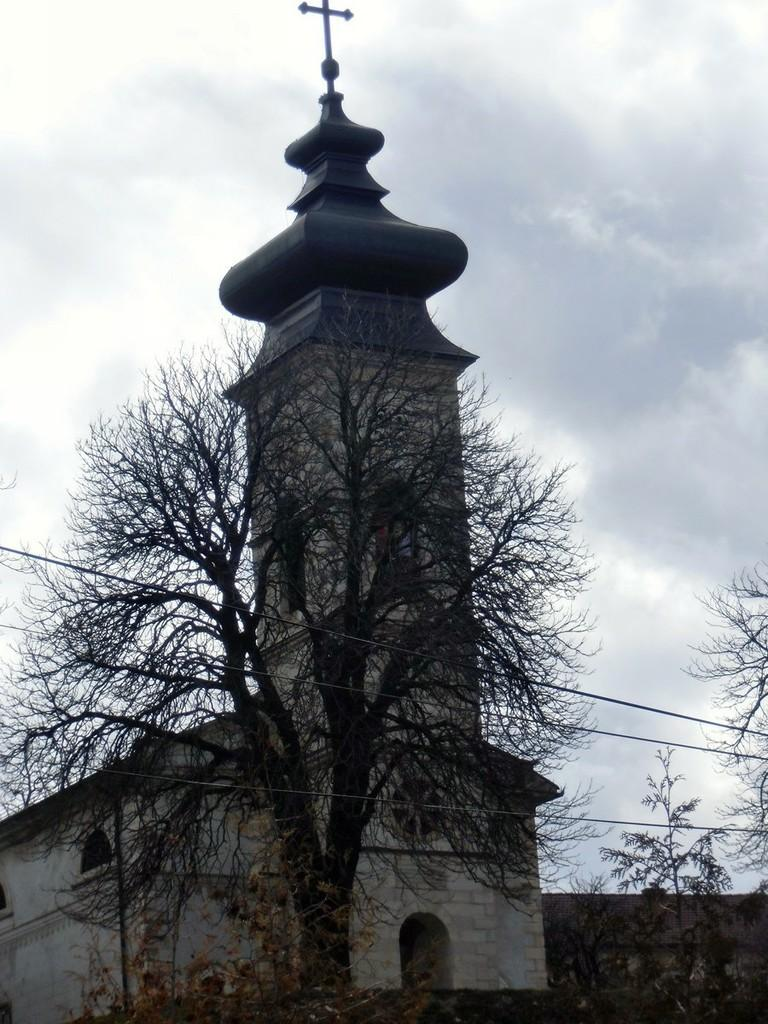What type of building is in the image? There is a church in the image. What other elements can be seen in the image besides the church? There are trees in the image. What is visible at the top of the image? The sky is visible at the top of the image. How would you describe the sky in the image? The sky appears to be cloudy. What health channel is being watched on the television in the image? There is no television present in the image, so it is not possible to determine what channel might be watched. 